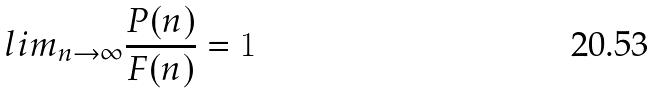Convert formula to latex. <formula><loc_0><loc_0><loc_500><loc_500>l i m _ { n \rightarrow \infty } \frac { P ( n ) } { F ( n ) } = 1</formula> 